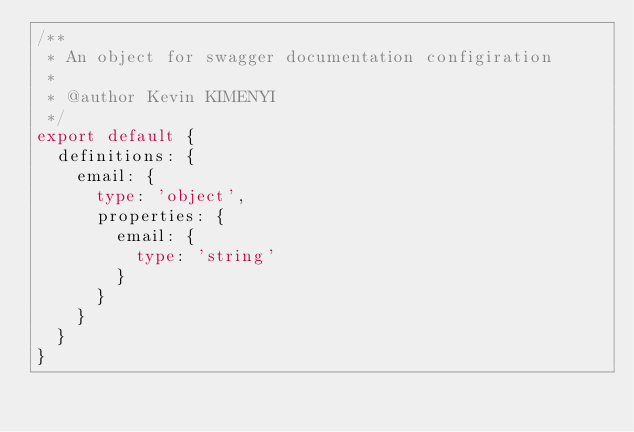Convert code to text. <code><loc_0><loc_0><loc_500><loc_500><_TypeScript_>/**
 * An object for swagger documentation configiration
 *
 * @author Kevin KIMENYI
 */
export default {
  definitions: {
    email: {
      type: 'object',
      properties: {
        email: {
          type: 'string'
        }
      }
    }
  }
}
</code> 